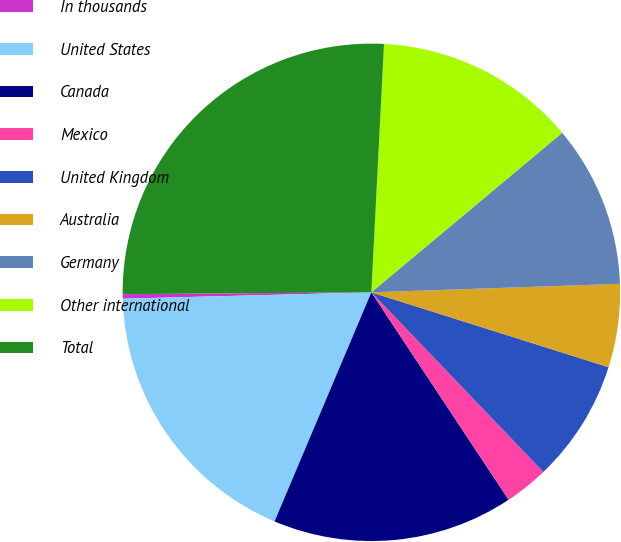<chart> <loc_0><loc_0><loc_500><loc_500><pie_chart><fcel>In thousands<fcel>United States<fcel>Canada<fcel>Mexico<fcel>United Kingdom<fcel>Australia<fcel>Germany<fcel>Other international<fcel>Total<nl><fcel>0.29%<fcel>18.23%<fcel>15.67%<fcel>2.85%<fcel>7.98%<fcel>5.41%<fcel>10.54%<fcel>13.11%<fcel>25.93%<nl></chart> 